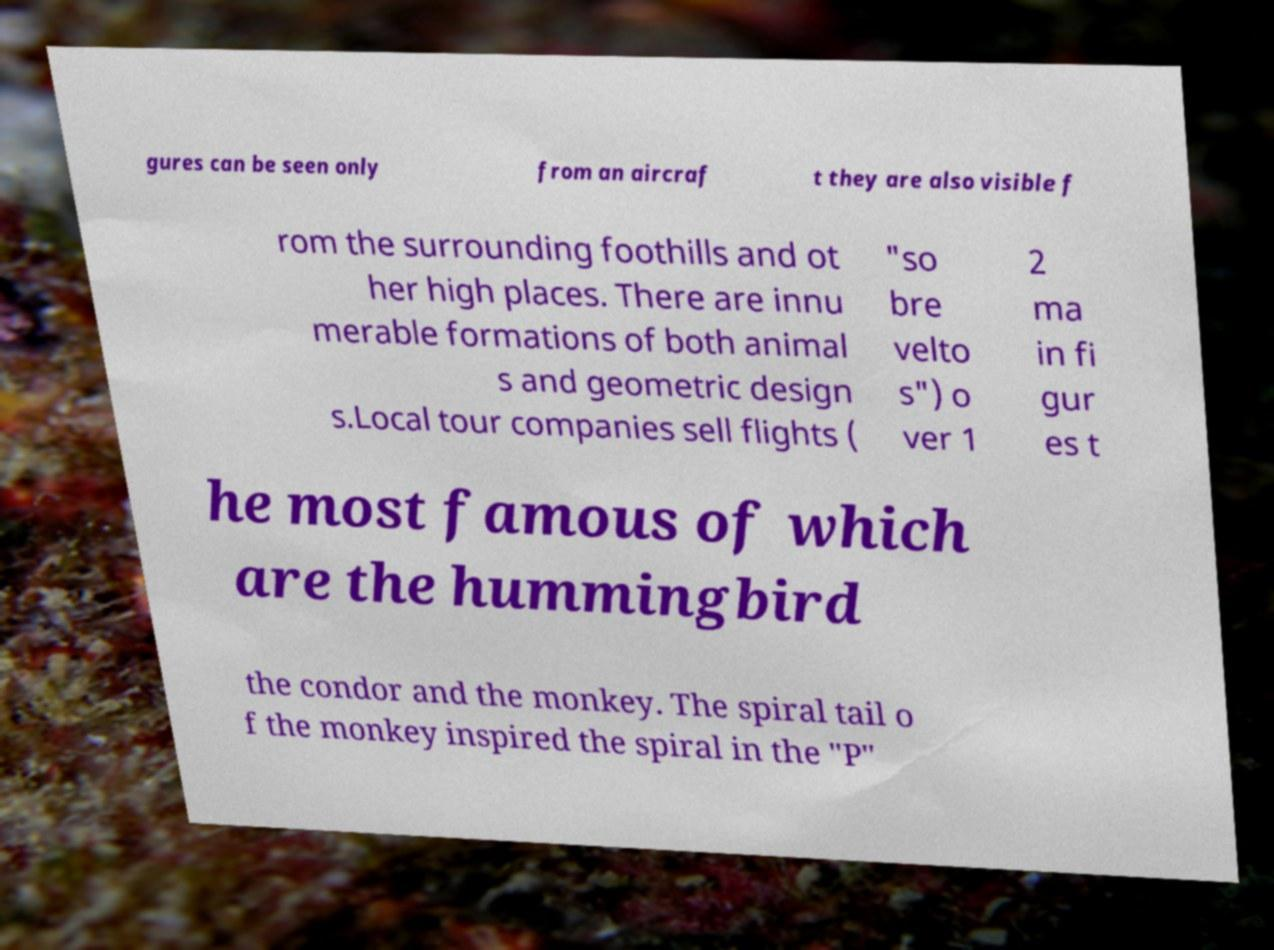What messages or text are displayed in this image? I need them in a readable, typed format. gures can be seen only from an aircraf t they are also visible f rom the surrounding foothills and ot her high places. There are innu merable formations of both animal s and geometric design s.Local tour companies sell flights ( "so bre velto s") o ver 1 2 ma in fi gur es t he most famous of which are the hummingbird the condor and the monkey. The spiral tail o f the monkey inspired the spiral in the "P" 